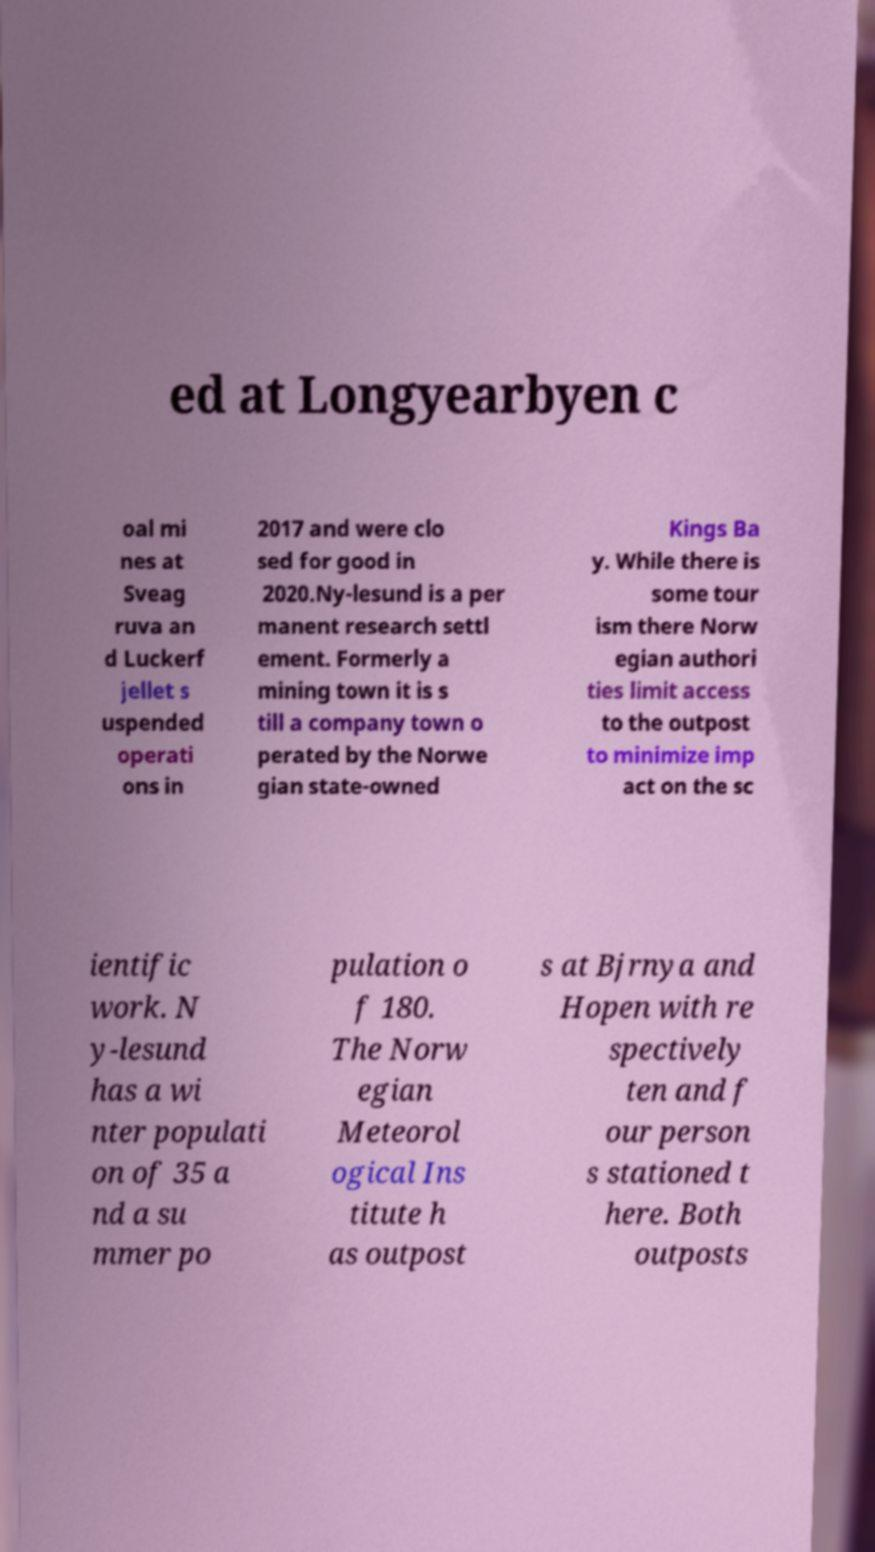Please identify and transcribe the text found in this image. ed at Longyearbyen c oal mi nes at Sveag ruva an d Luckerf jellet s uspended operati ons in 2017 and were clo sed for good in 2020.Ny-lesund is a per manent research settl ement. Formerly a mining town it is s till a company town o perated by the Norwe gian state-owned Kings Ba y. While there is some tour ism there Norw egian authori ties limit access to the outpost to minimize imp act on the sc ientific work. N y-lesund has a wi nter populati on of 35 a nd a su mmer po pulation o f 180. The Norw egian Meteorol ogical Ins titute h as outpost s at Bjrnya and Hopen with re spectively ten and f our person s stationed t here. Both outposts 